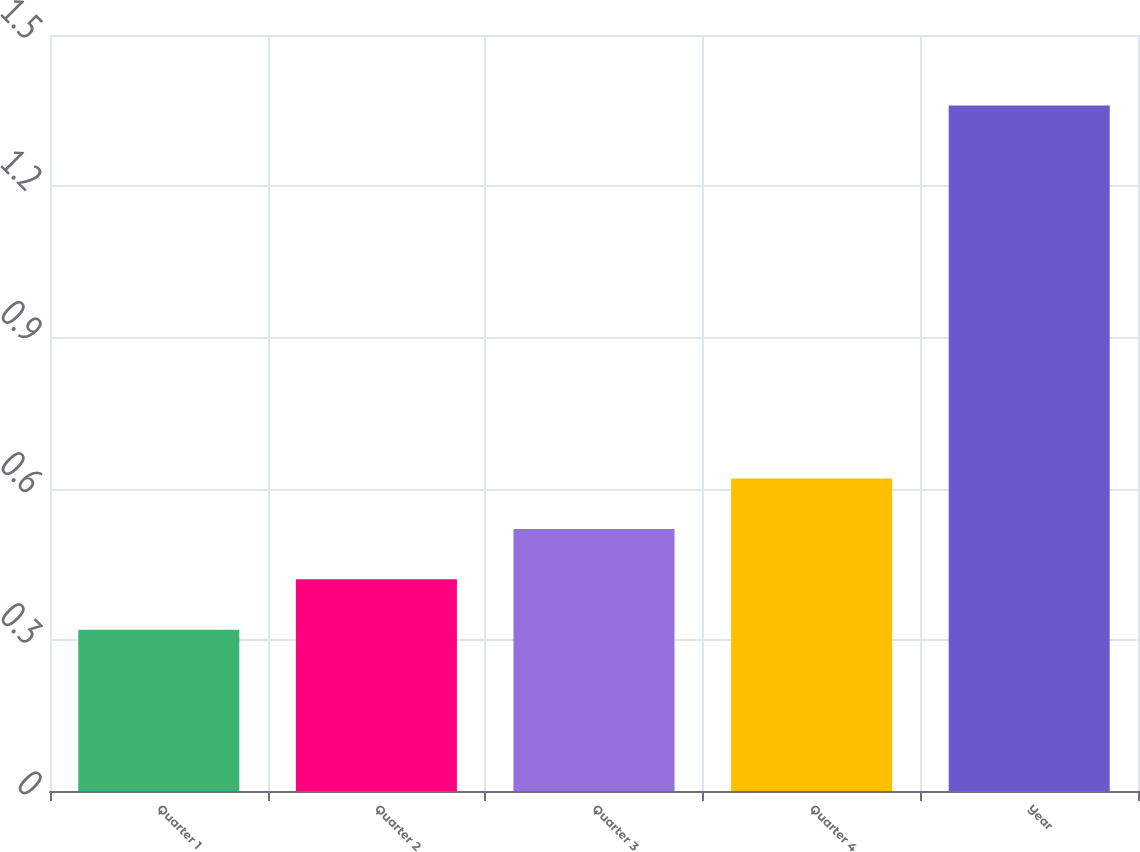<chart> <loc_0><loc_0><loc_500><loc_500><bar_chart><fcel>Quarter 1<fcel>Quarter 2<fcel>Quarter 3<fcel>Quarter 4<fcel>Year<nl><fcel>0.32<fcel>0.42<fcel>0.52<fcel>0.62<fcel>1.36<nl></chart> 